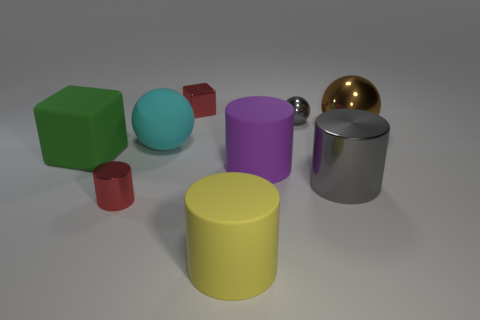Subtract all red cylinders. How many cylinders are left? 3 Subtract all red metallic cylinders. How many cylinders are left? 3 Add 1 brown matte cubes. How many objects exist? 10 Subtract all spheres. How many objects are left? 6 Subtract 0 blue cylinders. How many objects are left? 9 Subtract all gray cylinders. Subtract all yellow blocks. How many cylinders are left? 3 Subtract all large brown metallic balls. Subtract all gray metal balls. How many objects are left? 7 Add 8 large yellow cylinders. How many large yellow cylinders are left? 9 Add 6 tiny yellow metal balls. How many tiny yellow metal balls exist? 6 